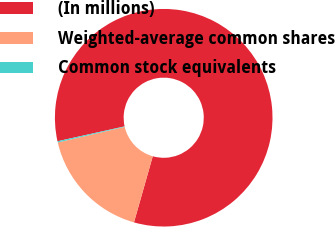<chart> <loc_0><loc_0><loc_500><loc_500><pie_chart><fcel>(In millions)<fcel>Weighted-average common shares<fcel>Common stock equivalents<nl><fcel>82.87%<fcel>16.94%<fcel>0.18%<nl></chart> 